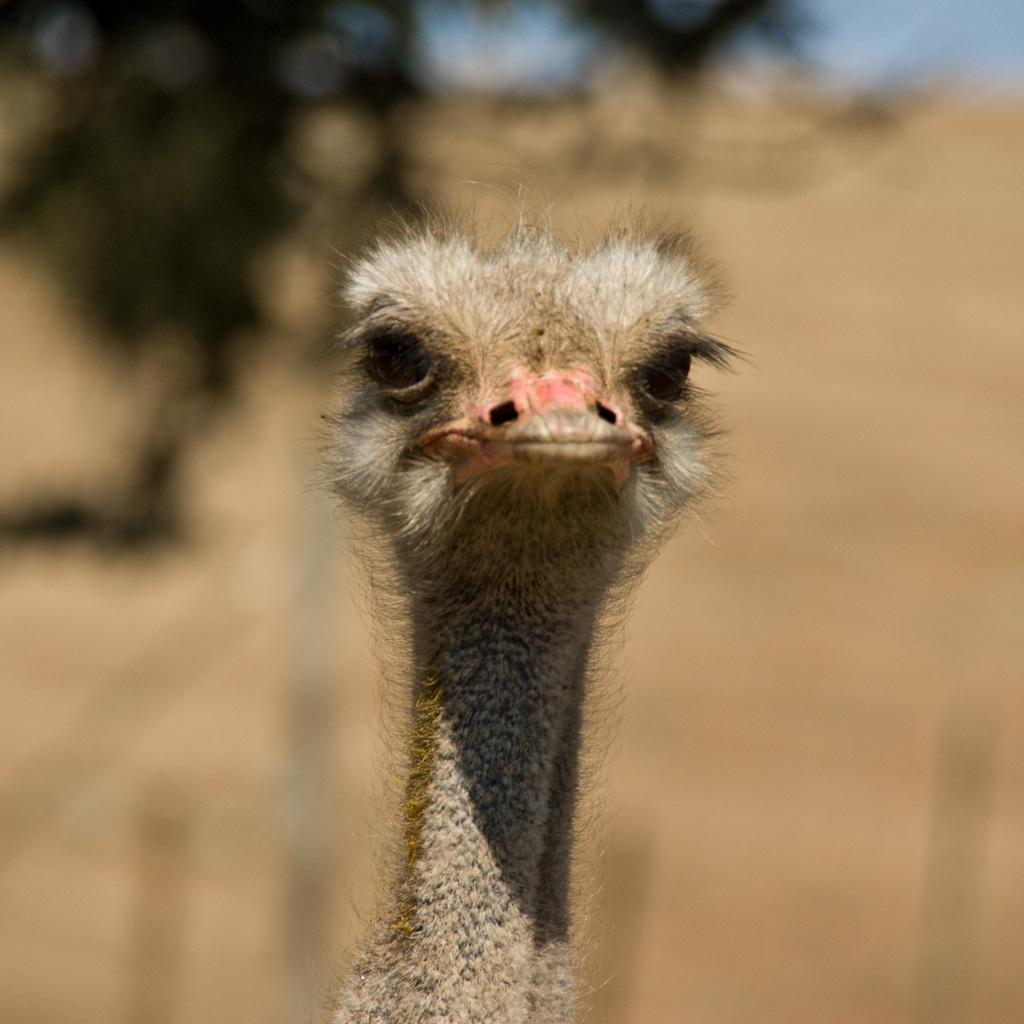What type of animal is in the foreground of the image? There is an animal in the foreground of the image, but the specific type cannot be determined from the provided facts. What can be seen in the background of the image? There are trees and sand visible in the background of the image. What force is causing the earthquake in the image? There is no earthquake present in the image, so it is not possible to determine what force might be causing it. 